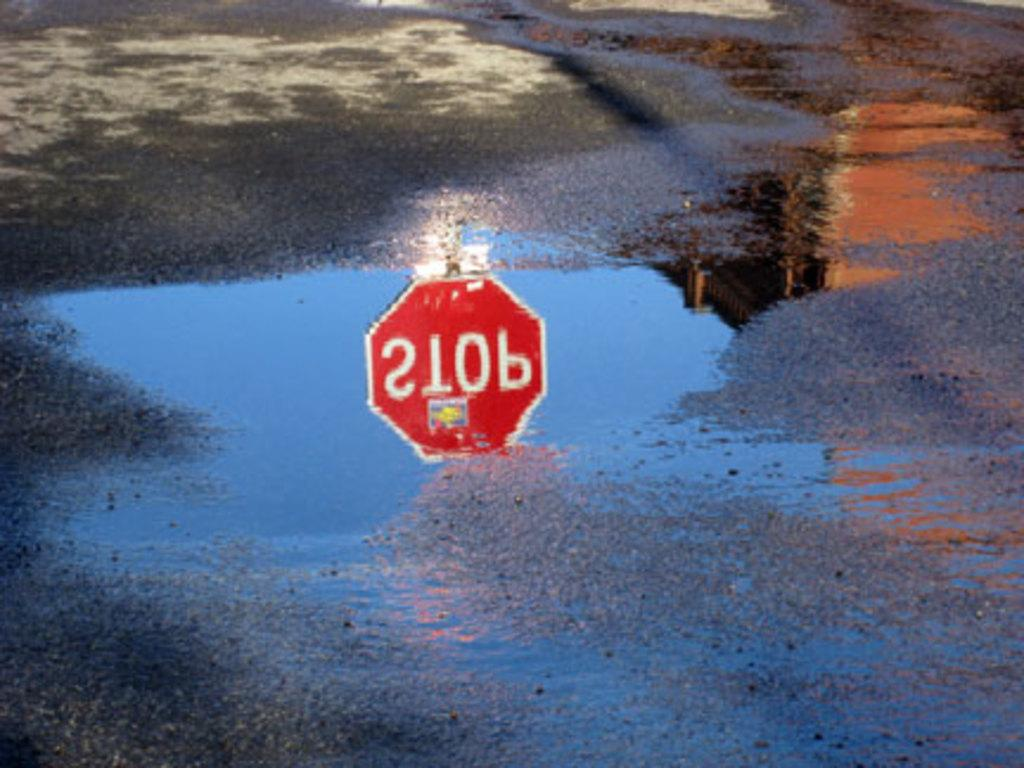<image>
Summarize the visual content of the image. Stop sign that is upside down in a reflection from a puddle on the ground. 